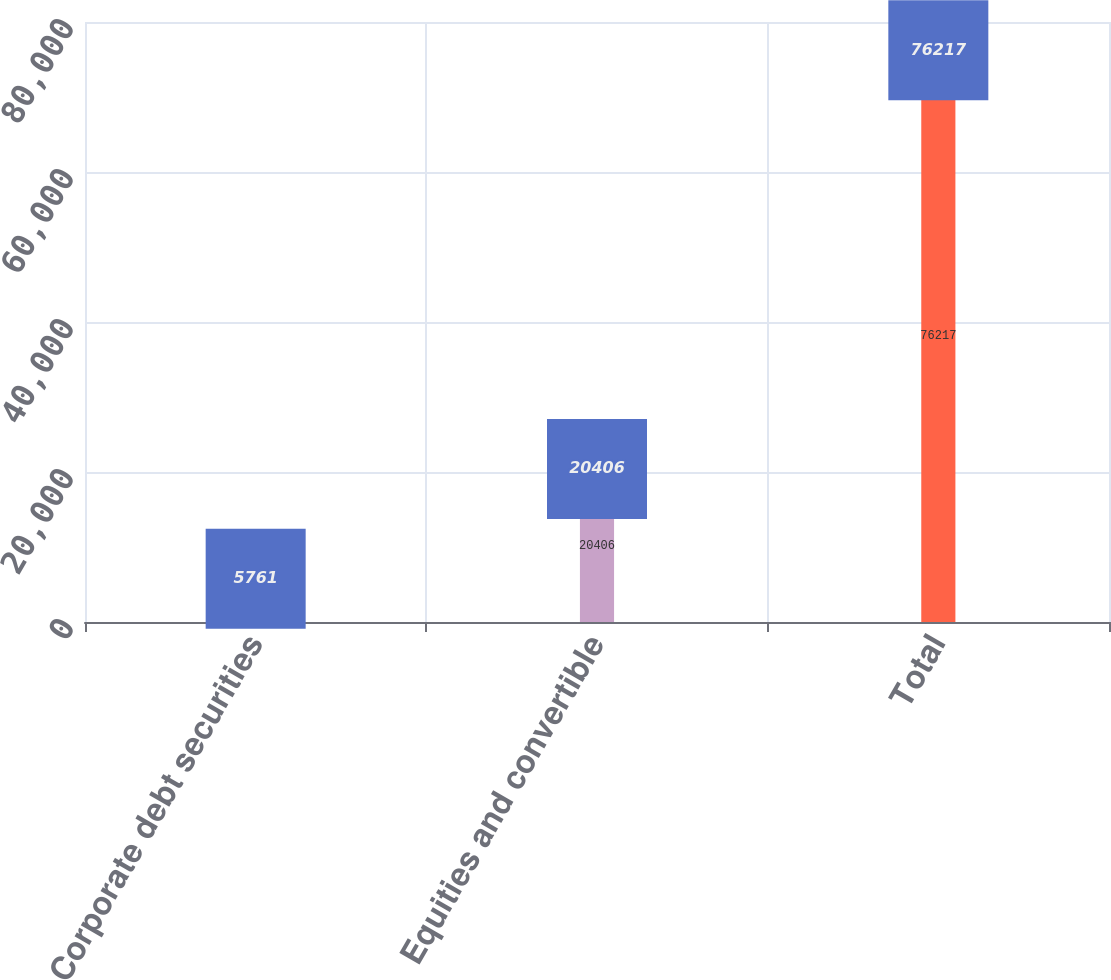<chart> <loc_0><loc_0><loc_500><loc_500><bar_chart><fcel>Corporate debt securities<fcel>Equities and convertible<fcel>Total<nl><fcel>5761<fcel>20406<fcel>76217<nl></chart> 